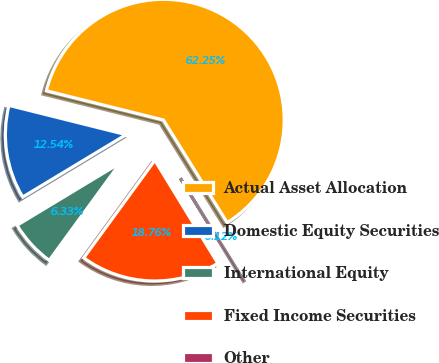Convert chart to OTSL. <chart><loc_0><loc_0><loc_500><loc_500><pie_chart><fcel>Actual Asset Allocation<fcel>Domestic Equity Securities<fcel>International Equity<fcel>Fixed Income Securities<fcel>Other<nl><fcel>62.25%<fcel>12.54%<fcel>6.33%<fcel>18.76%<fcel>0.12%<nl></chart> 